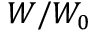<formula> <loc_0><loc_0><loc_500><loc_500>W / W _ { 0 }</formula> 